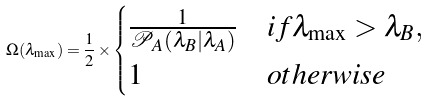<formula> <loc_0><loc_0><loc_500><loc_500>\Omega ( \lambda _ { \max } ) = \frac { 1 } { 2 } \times \begin{cases} \frac { 1 } { { \mathcal { P } } _ { A } ( \lambda _ { B } | \lambda _ { A } ) } & i f \lambda _ { \max } > \lambda _ { B } , \\ 1 & o t h e r w i s e \end{cases}</formula> 